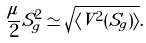Convert formula to latex. <formula><loc_0><loc_0><loc_500><loc_500>\frac { \mu } { 2 } S ^ { 2 } _ { g } \simeq \sqrt { \langle V ^ { 2 } ( S _ { g } ) \rangle } .</formula> 